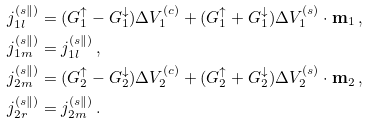Convert formula to latex. <formula><loc_0><loc_0><loc_500><loc_500>j _ { 1 l } ^ { ( s \| ) } & = ( G _ { 1 } ^ { \uparrow } - G _ { 1 } ^ { \downarrow } ) \Delta V _ { 1 } ^ { ( c ) } + ( G _ { 1 } ^ { \uparrow } + G _ { 1 } ^ { \downarrow } ) \Delta { V } _ { 1 } ^ { ( s ) } \cdot { \mathbf m } _ { 1 } \, , \\ j _ { 1 m } ^ { ( s \| ) } & = j _ { 1 l } ^ { ( s \| ) } \, , \\ j _ { 2 m } ^ { ( s \| ) } & = ( G _ { 2 } ^ { \uparrow } - G _ { 2 } ^ { \downarrow } ) \Delta V _ { 2 } ^ { ( c ) } + ( G _ { 2 } ^ { \uparrow } + G _ { 2 } ^ { \downarrow } ) \Delta { V } _ { 2 } ^ { ( s ) } \cdot { \mathbf m } _ { 2 } \, , \\ j _ { 2 r } ^ { ( s \| ) } & = j _ { 2 m } ^ { ( s \| ) } \, .</formula> 